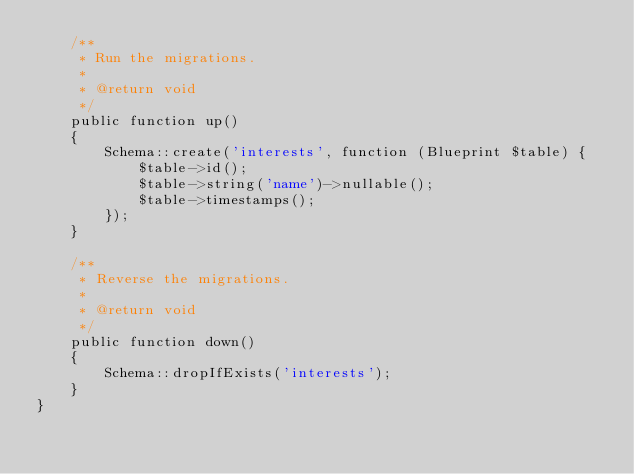<code> <loc_0><loc_0><loc_500><loc_500><_PHP_>    /**
     * Run the migrations.
     *
     * @return void
     */
    public function up()
    {
        Schema::create('interests', function (Blueprint $table) {
            $table->id();
            $table->string('name')->nullable();
            $table->timestamps();
        });
    }

    /**
     * Reverse the migrations.
     *
     * @return void
     */
    public function down()
    {
        Schema::dropIfExists('interests');
    }
}
</code> 